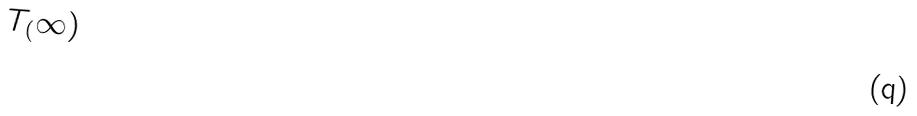<formula> <loc_0><loc_0><loc_500><loc_500>T _ { ( } \infty )</formula> 